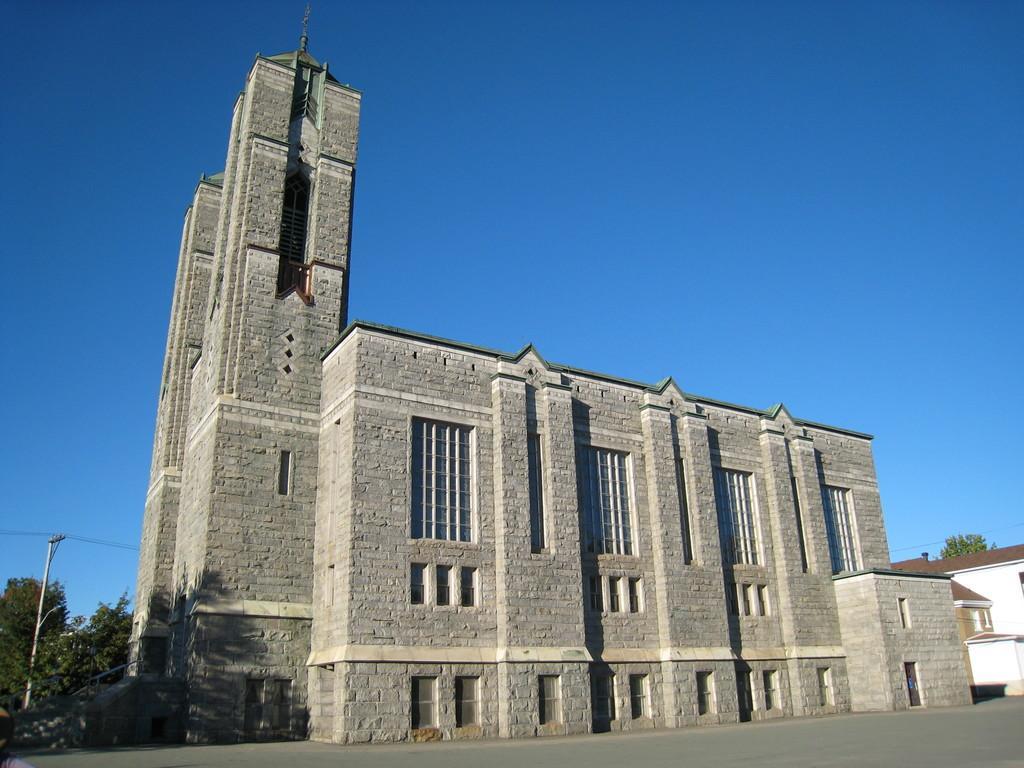Please provide a concise description of this image. In the foreground of this image, there is a road at the bottom. In the middle, there are buildings, trees, a pole and cables. At the top, there is the sky. 